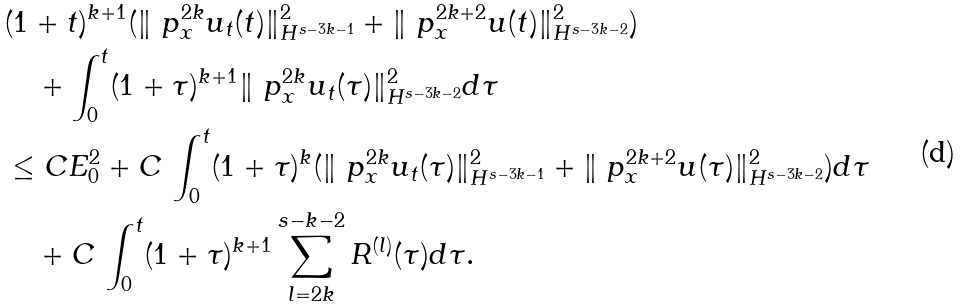<formula> <loc_0><loc_0><loc_500><loc_500>& ( 1 + t ) ^ { k + 1 } ( \| \ p ^ { 2 k } _ { x } u _ { t } ( t ) \| ^ { 2 } _ { H ^ { s - 3 k - 1 } } + \| \ p ^ { 2 k + 2 } _ { x } u ( t ) \| ^ { 2 } _ { H ^ { s - 3 k - 2 } } ) \\ & \quad + \int ^ { t } _ { 0 } ( 1 + \tau ) ^ { k + 1 } \| \ p ^ { 2 k } _ { x } u _ { t } ( \tau ) \| ^ { 2 } _ { H ^ { s - 3 k - 2 } } d \tau \\ & \leq C E _ { 0 } ^ { 2 } + C \, \int ^ { t } _ { 0 } ( 1 + \tau ) ^ { k } ( \| \ p ^ { 2 k } _ { x } u _ { t } ( \tau ) \| ^ { 2 } _ { H ^ { s - 3 k - 1 } } + \| \ p ^ { 2 k + 2 } _ { x } u ( \tau ) \| ^ { 2 } _ { H ^ { s - 3 k - 2 } } ) d \tau \\ & \quad + C \, \int ^ { t } _ { 0 } ( 1 + \tau ) ^ { k + 1 } \sum _ { l = 2 k } ^ { s - k - 2 } R ^ { ( l ) } ( \tau ) d \tau .</formula> 